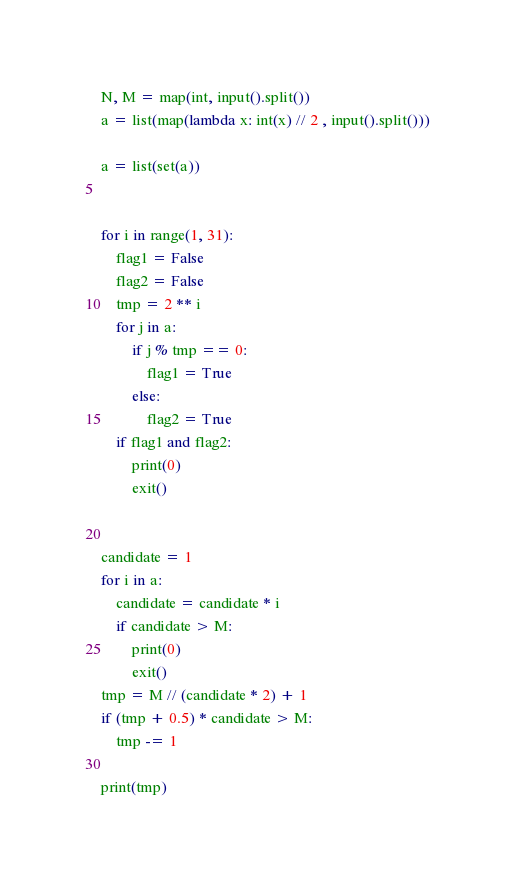Convert code to text. <code><loc_0><loc_0><loc_500><loc_500><_Python_>N, M = map(int, input().split())
a = list(map(lambda x: int(x) // 2 , input().split()))

a = list(set(a))


for i in range(1, 31):
    flag1 = False
    flag2 = False
    tmp = 2 ** i
    for j in a:
        if j % tmp == 0:
            flag1 = True
        else:
            flag2 = True
    if flag1 and flag2:
        print(0)
        exit()


candidate = 1
for i in a:
    candidate = candidate * i
    if candidate > M:
        print(0)
        exit()
tmp = M // (candidate * 2) + 1
if (tmp + 0.5) * candidate > M:
    tmp -= 1

print(tmp)
</code> 